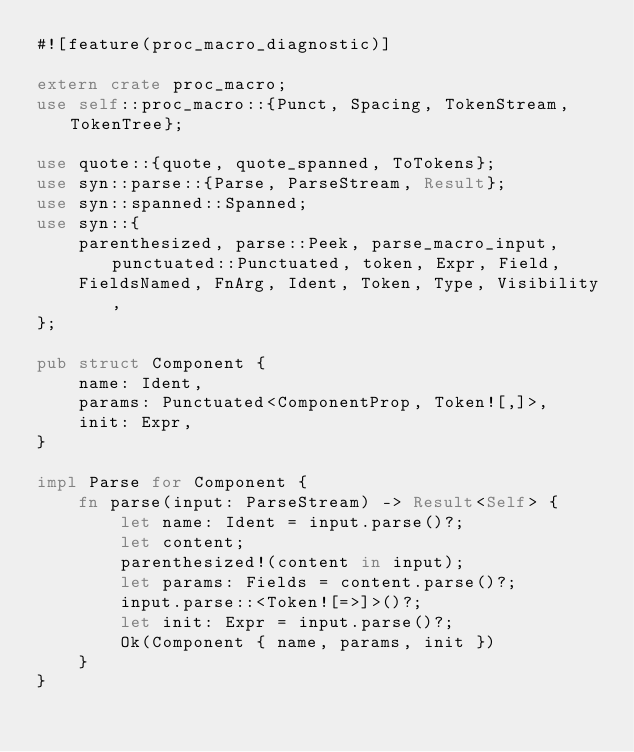Convert code to text. <code><loc_0><loc_0><loc_500><loc_500><_Rust_>#![feature(proc_macro_diagnostic)]

extern crate proc_macro;
use self::proc_macro::{Punct, Spacing, TokenStream, TokenTree};

use quote::{quote, quote_spanned, ToTokens};
use syn::parse::{Parse, ParseStream, Result};
use syn::spanned::Spanned;
use syn::{
    parenthesized, parse::Peek, parse_macro_input, punctuated::Punctuated, token, Expr, Field,
    FieldsNamed, FnArg, Ident, Token, Type, Visibility,
};

pub struct Component {
    name: Ident,
    params: Punctuated<ComponentProp, Token![,]>,
    init: Expr,
}

impl Parse for Component {
    fn parse(input: ParseStream) -> Result<Self> {
        let name: Ident = input.parse()?;
        let content;
        parenthesized!(content in input);
        let params: Fields = content.parse()?;
        input.parse::<Token![=>]>()?;
        let init: Expr = input.parse()?;
        Ok(Component { name, params, init })
    }
}
</code> 